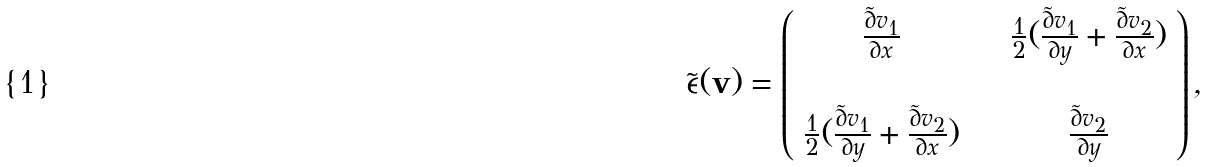<formula> <loc_0><loc_0><loc_500><loc_500>\tilde { \epsilon } ( \mathbf v ) = \left ( \begin{array} { c c } \frac { \tilde { \partial } v _ { 1 } } { \partial x } & \quad \frac { 1 } { 2 } ( \frac { \tilde { \partial } v _ { 1 } } { \partial y } + \frac { \tilde { \partial } v _ { 2 } } { \partial x } ) \\ \\ \frac { 1 } { 2 } ( \frac { \tilde { \partial } v _ { 1 } } { \partial y } + \frac { \tilde { \partial } v _ { 2 } } { \partial x } ) & \quad \frac { \tilde { \partial } v _ { 2 } } { \partial y } \end{array} \right ) ,</formula> 